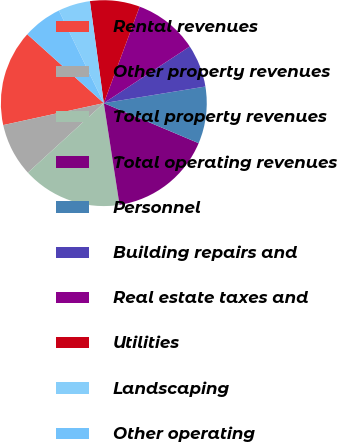Convert chart. <chart><loc_0><loc_0><loc_500><loc_500><pie_chart><fcel>Rental revenues<fcel>Other property revenues<fcel>Total property revenues<fcel>Total operating revenues<fcel>Personnel<fcel>Building repairs and<fcel>Real estate taxes and<fcel>Utilities<fcel>Landscaping<fcel>Other operating<nl><fcel>15.08%<fcel>8.38%<fcel>15.64%<fcel>16.2%<fcel>8.94%<fcel>6.7%<fcel>10.06%<fcel>7.82%<fcel>5.03%<fcel>6.15%<nl></chart> 